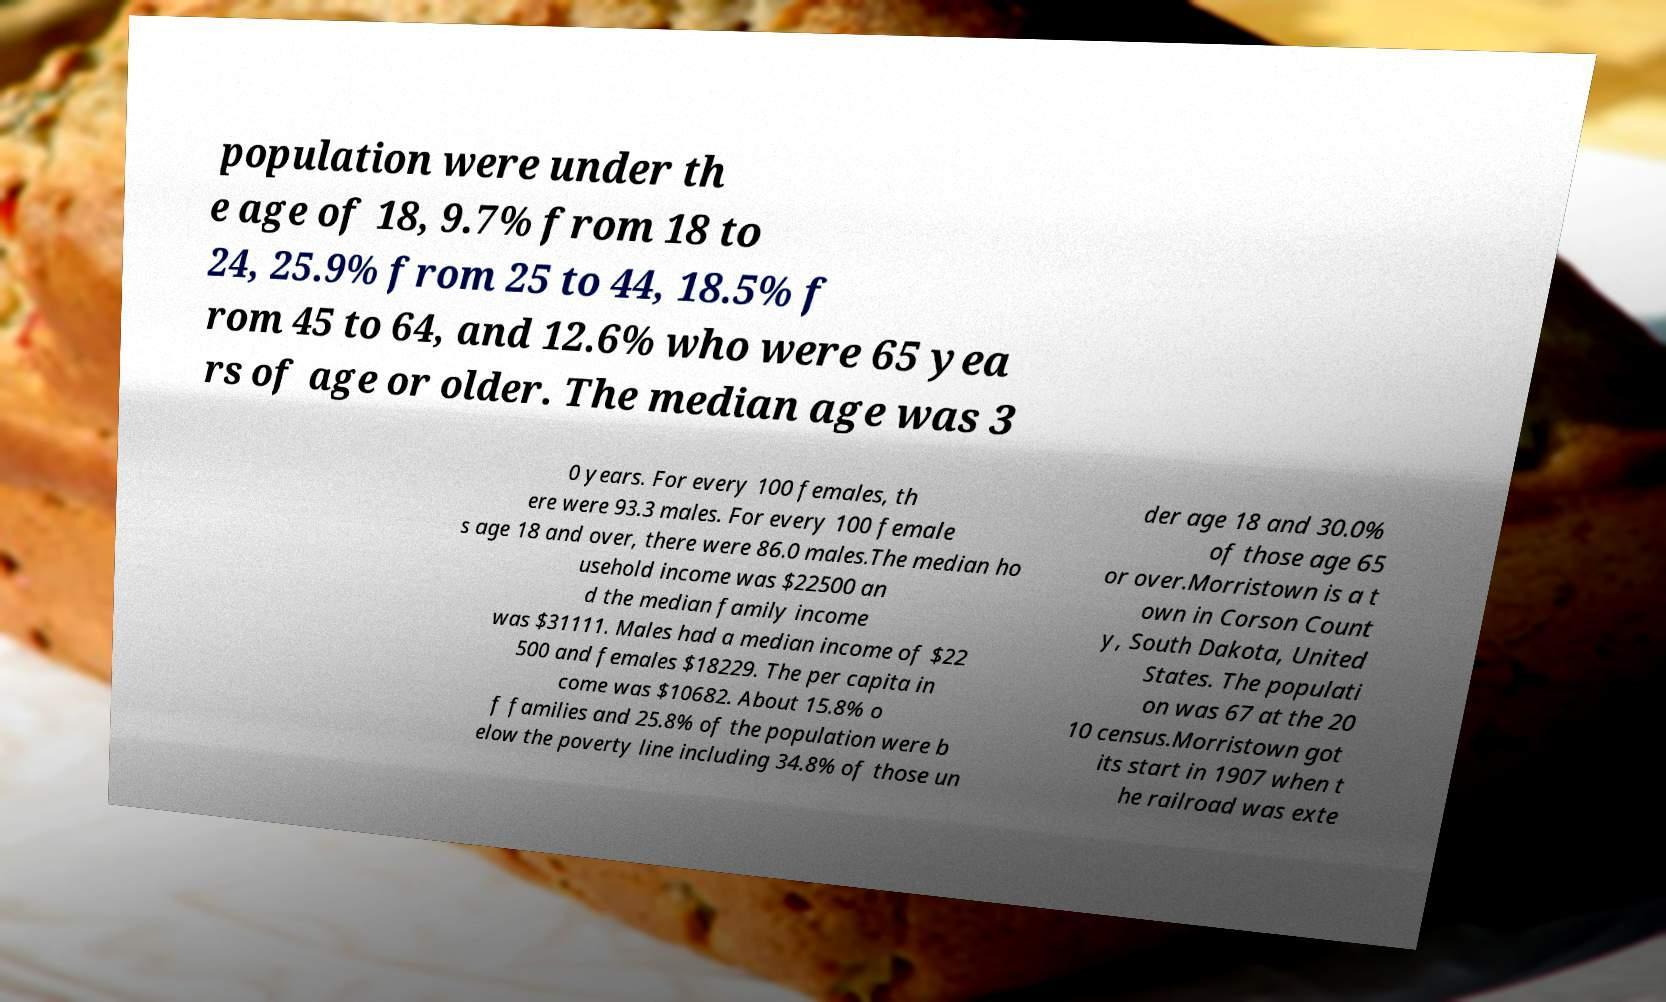Can you accurately transcribe the text from the provided image for me? population were under th e age of 18, 9.7% from 18 to 24, 25.9% from 25 to 44, 18.5% f rom 45 to 64, and 12.6% who were 65 yea rs of age or older. The median age was 3 0 years. For every 100 females, th ere were 93.3 males. For every 100 female s age 18 and over, there were 86.0 males.The median ho usehold income was $22500 an d the median family income was $31111. Males had a median income of $22 500 and females $18229. The per capita in come was $10682. About 15.8% o f families and 25.8% of the population were b elow the poverty line including 34.8% of those un der age 18 and 30.0% of those age 65 or over.Morristown is a t own in Corson Count y, South Dakota, United States. The populati on was 67 at the 20 10 census.Morristown got its start in 1907 when t he railroad was exte 